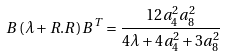<formula> <loc_0><loc_0><loc_500><loc_500>B \left ( \lambda + R . R \right ) B ^ { T } = \frac { 1 2 a _ { 4 } ^ { 2 } a _ { 8 } ^ { 2 } } { 4 \lambda + 4 a _ { 4 } ^ { 2 } + 3 a _ { 8 } ^ { 2 } }</formula> 